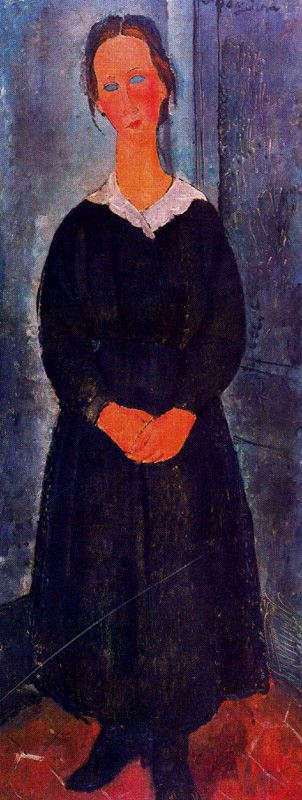What's happening in the scene? The painting captures a somber, introspective woman standing in an indoor setting, dressed in a stark black dress contrasted by a bright white collar. Her expression and the closed posture of her clasped hands suggest introspection or melancholy, inviting viewers to ponder her thoughts or circumstances. The room's subdued blue-gray tones and the striking red floor enhance the emotional depth of the scene, typical of post-impressionism’s interest in conveying mood through color. This artwork not only showcases the physical depiction of the woman but also subtly invites an exploration of her inner life. 